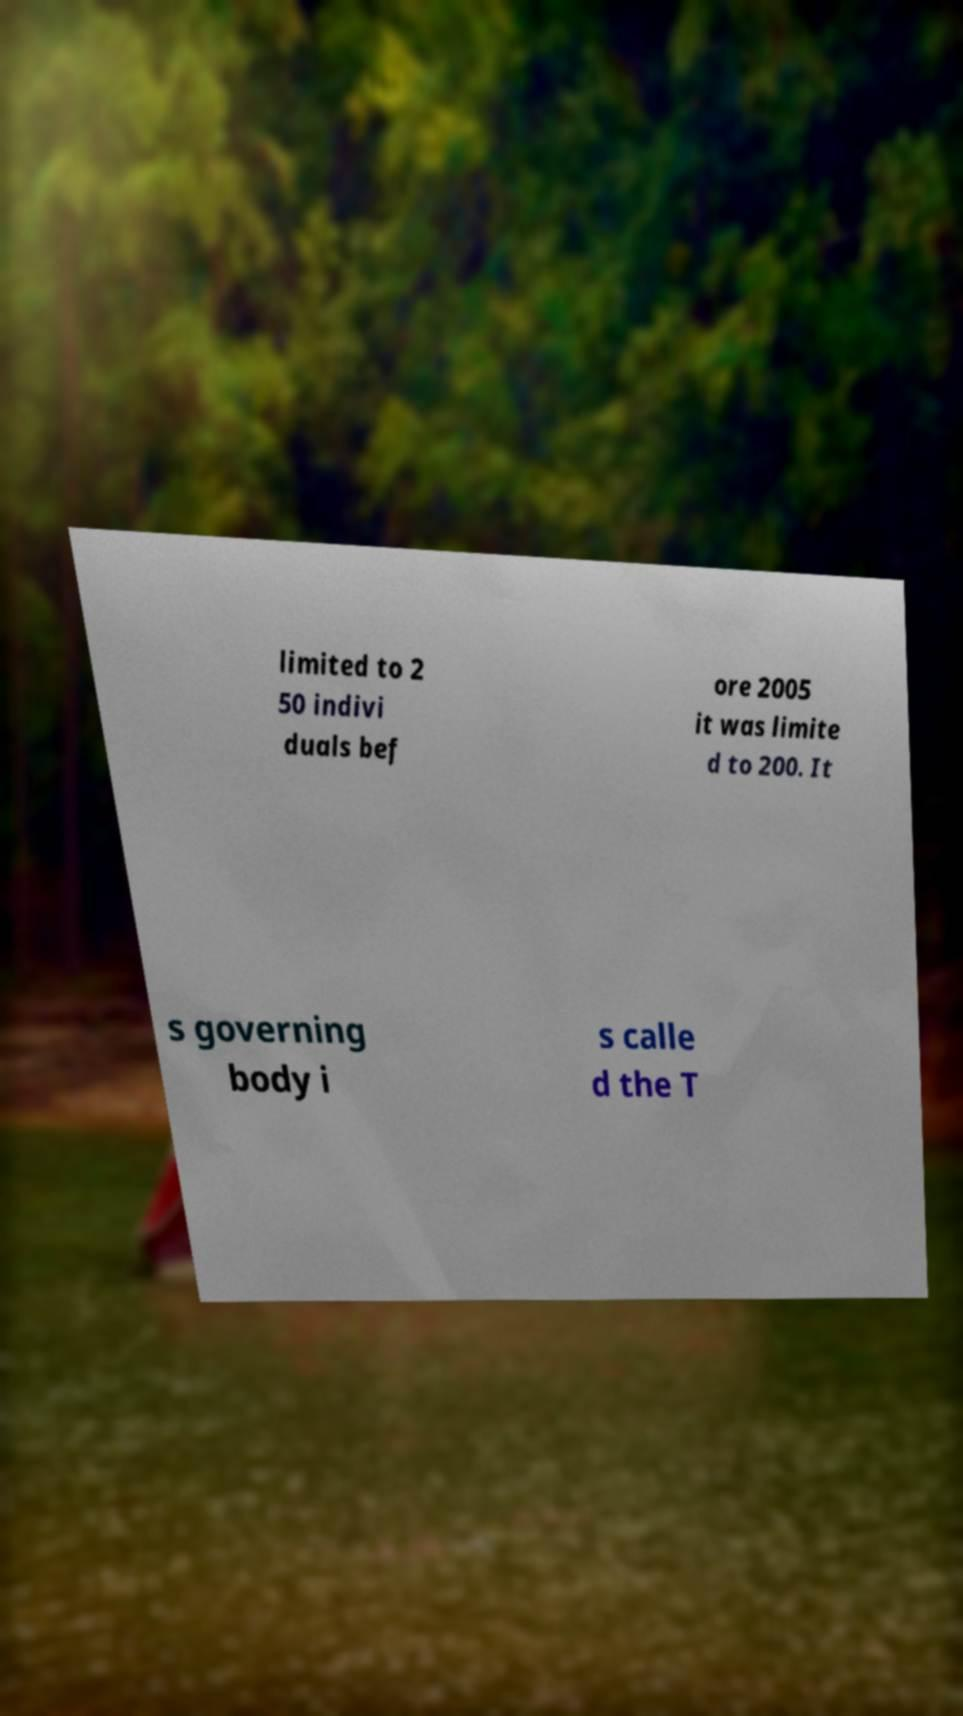Can you accurately transcribe the text from the provided image for me? limited to 2 50 indivi duals bef ore 2005 it was limite d to 200. It s governing body i s calle d the T 